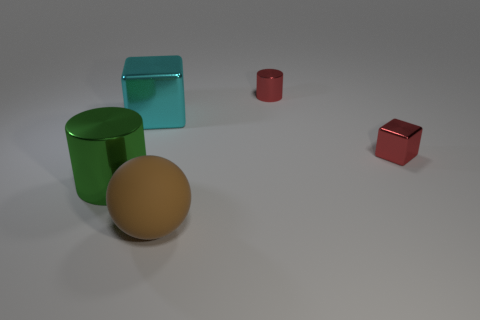Is there anything else that has the same material as the sphere?
Provide a short and direct response. No. Are there an equal number of big brown objects behind the tiny red block and brown spheres on the right side of the red cylinder?
Your answer should be compact. Yes. Does the red cube have the same material as the red cylinder?
Provide a short and direct response. Yes. What number of gray things are small objects or big metallic blocks?
Offer a very short reply. 0. What number of other big cyan shiny things have the same shape as the cyan metallic thing?
Provide a succinct answer. 0. What is the material of the cyan cube?
Your answer should be very brief. Metal. Are there the same number of cyan metal things that are in front of the large rubber sphere and tiny yellow rubber objects?
Give a very brief answer. Yes. What shape is the red metal object that is the same size as the red block?
Provide a succinct answer. Cylinder. Are there any large cyan objects behind the large thing that is to the left of the big block?
Offer a terse response. Yes. How many small objects are blue rubber blocks or brown balls?
Provide a succinct answer. 0. 